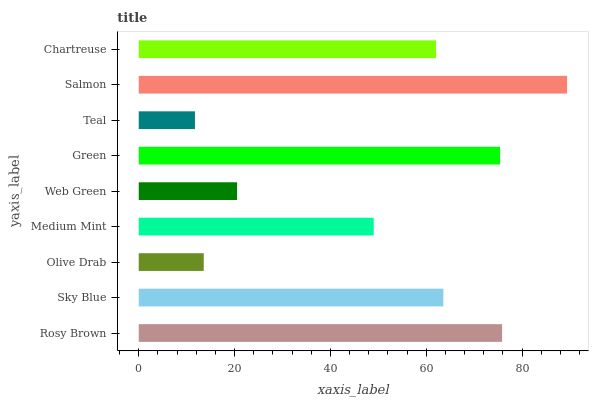Is Teal the minimum?
Answer yes or no. Yes. Is Salmon the maximum?
Answer yes or no. Yes. Is Sky Blue the minimum?
Answer yes or no. No. Is Sky Blue the maximum?
Answer yes or no. No. Is Rosy Brown greater than Sky Blue?
Answer yes or no. Yes. Is Sky Blue less than Rosy Brown?
Answer yes or no. Yes. Is Sky Blue greater than Rosy Brown?
Answer yes or no. No. Is Rosy Brown less than Sky Blue?
Answer yes or no. No. Is Chartreuse the high median?
Answer yes or no. Yes. Is Chartreuse the low median?
Answer yes or no. Yes. Is Web Green the high median?
Answer yes or no. No. Is Salmon the low median?
Answer yes or no. No. 